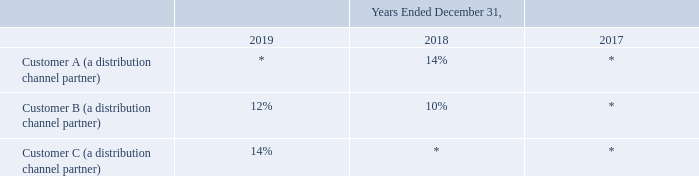Concentration of Credit Risk and Significant Customers
Financial instruments that potentially subject us to concentrations of credit risk consist of cash, cash equivalents, marketable securities and accounts receivable. Our cash, cash equivalents and marketable securities are held and invested in high-credit quality financial instruments by recognized financial institutions and are subject to minimum credit risk.
Our accounts receivable are unsecured and represent amounts due to us based on contractual obligations of our customers. We mitigate credit risk in respect to accounts receivable by performing periodic credit evaluations based on a number of factors, including past transaction experience, evaluation of credit history and review of the invoicing terms of the contract. We generally do not require our customers to provide collateral to support accounts receivable.
Significant customers, including distribution channel partners and direct customers, are those which represent 10% or more of our total revenue for each period presented or our gross accounts receivable balance as of each respective balance sheet date. Revenues from our significant customers as a percentage of our total revenue are as follows
*represents less than 10% of total revenue
As of December 31, 2019, two customers accounted for 17% and 12% of our total gross accounts receivable.
As of December 31, 2018, two customers accounted for 16% and 12% of our total gross accounts receivable
What is the proportion of revenue derived from significant customers in 2019?
Answer scale should be: percent. 12% + 14% 
Answer: 26. What are some examples of financial instruments that can subject the company to credit risk? Cash, cash equivalents, marketable securities and accounts receivable. How does the company mitigate its credit risk pertaining to accounts receivable? Performing periodic credit evaluations based on a number of factors, including past transaction experience, evaluation of credit history and review of the invoicing terms of the contract. What is the total proportion from Customer B and C of the company's gross accounts receivable  in 2019?
Answer scale should be: percent. 17+12
Answer: 29. How does the company determine its significant customers? Significant customers, including distribution channel partners and direct customers, are those which represent 10% or more of our total revenue for each period presented or our gross accounts receivable balance as of each respective balance sheet date. What is the company's total revenue earned from Customer A and B between 2018 and 2019?
Answer scale should be: percent. 14 + 12+10
Answer: 36. 